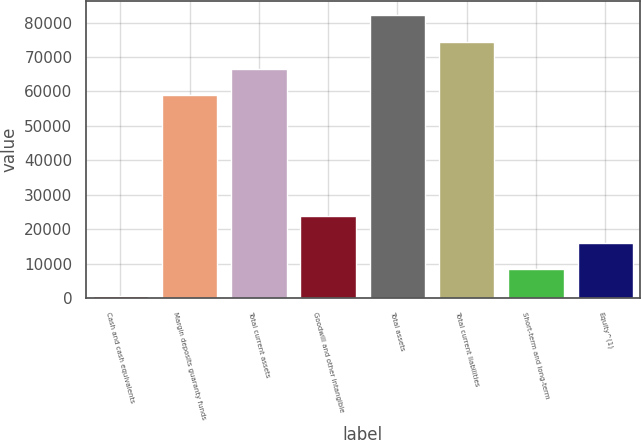Convert chart. <chart><loc_0><loc_0><loc_500><loc_500><bar_chart><fcel>Cash and cash equivalents<fcel>Margin deposits guaranty funds<fcel>Total current assets<fcel>Goodwill and other intangible<fcel>Total assets<fcel>Total current liabilities<fcel>Short-term and long-term<fcel>Equity^(1)<nl><fcel>627<fcel>58905<fcel>66641<fcel>23835<fcel>82113<fcel>74377<fcel>8363<fcel>16099<nl></chart> 